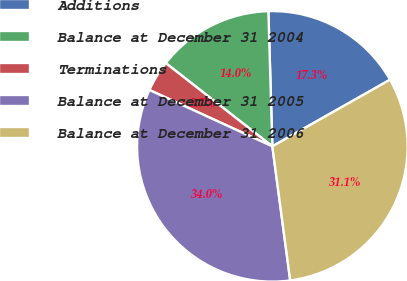Convert chart. <chart><loc_0><loc_0><loc_500><loc_500><pie_chart><fcel>Additions<fcel>Balance at December 31 2004<fcel>Terminations<fcel>Balance at December 31 2005<fcel>Balance at December 31 2006<nl><fcel>17.27%<fcel>13.98%<fcel>3.71%<fcel>33.95%<fcel>31.09%<nl></chart> 